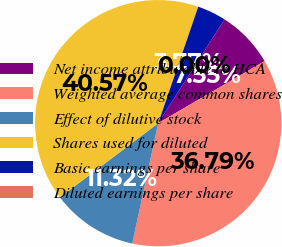Convert chart to OTSL. <chart><loc_0><loc_0><loc_500><loc_500><pie_chart><fcel>Net income attributable to HCA<fcel>Weighted average common shares<fcel>Effect of dilutive stock<fcel>Shares used for diluted<fcel>Basic earnings per share<fcel>Diluted earnings per share<nl><fcel>7.55%<fcel>36.79%<fcel>11.32%<fcel>40.57%<fcel>3.77%<fcel>0.0%<nl></chart> 